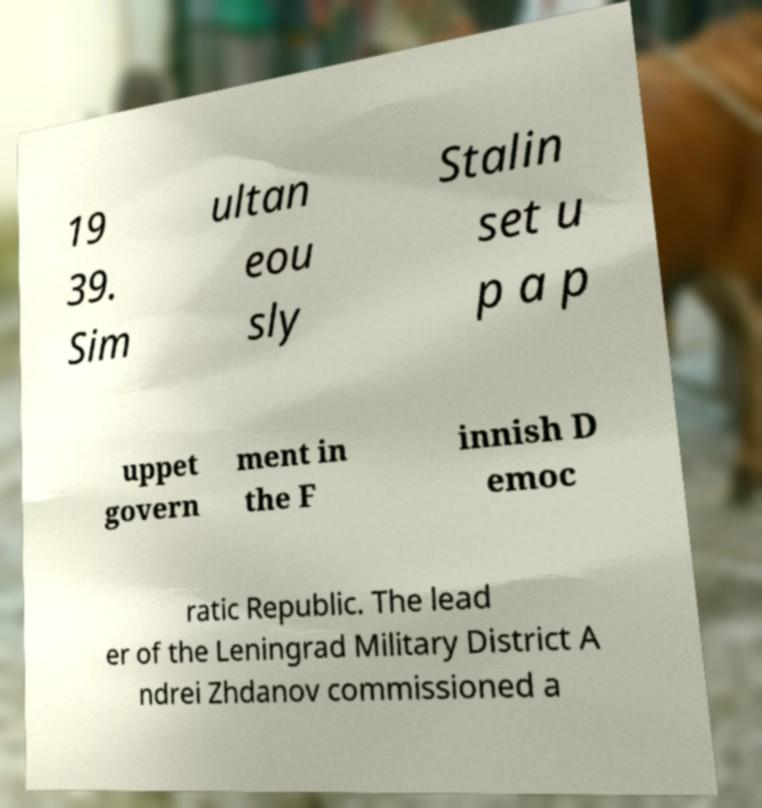Could you extract and type out the text from this image? 19 39. Sim ultan eou sly Stalin set u p a p uppet govern ment in the F innish D emoc ratic Republic. The lead er of the Leningrad Military District A ndrei Zhdanov commissioned a 